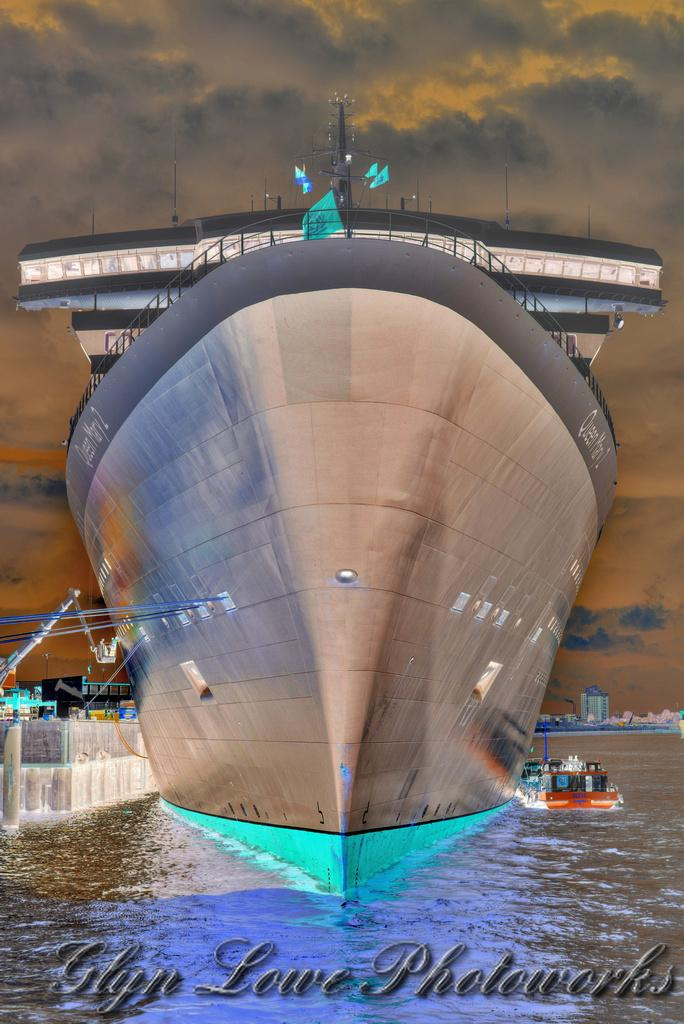What is in the water in the image? There are ships in the water in the image. What can be seen in the background of the image? There are buildings and the sky visible in the background of the image. What is written at the bottom of the image? There is some text written at the bottom of the image. How many people are in the crowd in the image? There is no crowd present in the image; it features ships in the water, buildings in the background, and text at the bottom. 